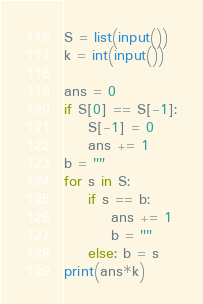<code> <loc_0><loc_0><loc_500><loc_500><_Python_>S = list(input())
k = int(input())

ans = 0
if S[0] == S[-1]:
    S[-1] = 0
    ans += 1
b = ""
for s in S:
    if s == b: 
        ans += 1
        b = ""
    else: b = s
print(ans*k)</code> 